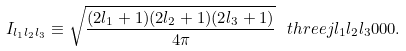<formula> <loc_0><loc_0><loc_500><loc_500>I _ { l _ { 1 } l _ { 2 } l _ { 3 } } \equiv \sqrt { \frac { ( 2 l _ { 1 } + 1 ) ( 2 l _ { 2 } + 1 ) ( 2 l _ { 3 } + 1 ) } { 4 \pi } } \ t h r e e j { l _ { 1 } } { l _ { 2 } } { l _ { 3 } } { 0 } { 0 } { 0 } .</formula> 